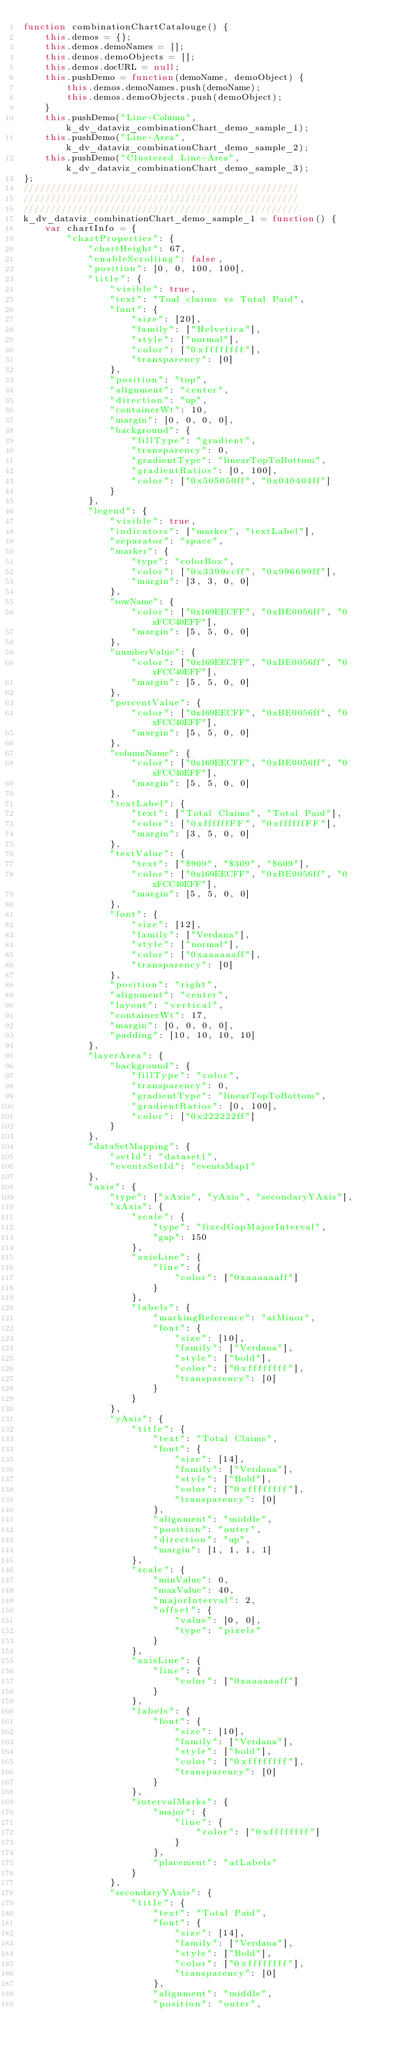<code> <loc_0><loc_0><loc_500><loc_500><_JavaScript_>function combinationChartCatalouge() {
    this.demos = {};
    this.demos.demoNames = [];
    this.demos.demoObjects = [];
    this.demos.docURL = null;
    this.pushDemo = function(demoName, demoObject) {
        this.demos.demoNames.push(demoName);
        this.demos.demoObjects.push(demoObject);
    }
    this.pushDemo("Line+Column", k_dv_dataviz_combinationChart_demo_sample_1);
    this.pushDemo("Line+Area", k_dv_dataviz_combinationChart_demo_sample_2);
    this.pushDemo("Clustered Line+Area", k_dv_dataviz_combinationChart_demo_sample_3);
};
///////////////////////////////////////////////////
///////////////////////////////////////////////////
///////////////////////////////////////////////////
k_dv_dataviz_combinationChart_demo_sample_1 = function() {
    var chartInfo = {
        "chartProperties": {
            "chartHeight": 67,
            "enableScrolling": false,
            "position": [0, 0, 100, 100],
            "title": {
                "visible": true,
                "text": "Toal claims vs Total Paid",
                "font": {
                    "size": [20],
                    "family": ["Helvetica"],
                    "style": ["normal"],
                    "color": ["0xffffffff"],
                    "transparency": [0]
                },
                "position": "top",
                "alignment": "center",
                "direction": "up",
                "containerWt": 10,
                "margin": [0, 0, 0, 0],
                "background": {
                    "fillType": "gradient",
                    "transparency": 0,
                    "gradientType": "linearTopToBottom",
                    "gradientRatios": [0, 100],
                    "color": ["0x505050ff", "0x040404ff"]
                }
            },
            "legend": {
                "visible": true,
                "indicators": ["marker", "textLabel"],
                "separator": "space",
                "marker": {
                    "type": "colorBox",
                    "color": ["0x3399ccff", "0x996699ff"],
                    "margin": [3, 3, 0, 0]
                },
                "rowName": {
                    "color": ["0x169EECFF", "0xBE0056ff", "0xFCC40EFF"],
                    "margin": [5, 5, 0, 0]
                },
                "numberValue": {
                    "color": ["0x169EECFF", "0xBE0056ff", "0xFCC40EFF"],
                    "margin": [5, 5, 0, 0]
                },
                "percentValue": {
                    "color": ["0x169EECFF", "0xBE0056ff", "0xFCC40EFF"],
                    "margin": [5, 5, 0, 0]
                },
                "columnName": {
                    "color": ["0x169EECFF", "0xBE0056ff", "0xFCC40EFF"],
                    "margin": [5, 5, 0, 0]
                },
                "textLabel": {
                    "text": ["Total Claims", "Total Paid"],
                    "color": ["0xffffffFF", "0xffffffFF"],
                    "margin": [3, 5, 0, 0]
                },
                "textValue": {
                    "text": ["$909", "$309", "$609"],
                    "color": ["0x169EECFF", "0xBE0056ff", "0xFCC40EFF"],
                    "margin": [5, 5, 0, 0]
                },
                "font": {
                    "size": [12],
                    "family": ["Verdana"],
                    "style": ["normal"],
                    "color": ["0xaaaaaaff"],
                    "transparency": [0]
                },
                "position": "right",
                "alignment": "center",
                "layout": "vertical",
                "containerWt": 17,
                "margin": [0, 0, 0, 0],
                "padding": [10, 10, 10, 10]
            },
            "layerArea": {
                "background": {
                    "fillType": "color",
                    "transparency": 0,
                    "gradientType": "linearTopToBottom",
                    "gradientRatios": [0, 100],
                    "color": ["0x222222ff"]
                }
            },
            "dataSetMapping": {
                "setId": "dataset1",
                "eventsSetId": "eventsMap1"
            },
            "axis": {
                "type": ["xAxis", "yAxis", "secondaryYAxis"],
                "xAxis": {
                    "scale": {
                        "type": "fixedGapMajorInterval",
                        "gap": 150
                    },
                    "axisLine": {
                        "line": {
                            "color": ["0xaaaaaaff"]
                        }
                    },
                    "labels": {
                        "markingReference": "atMinor",
                        "font": {
                            "size": [10],
                            "family": ["Verdana"],
                            "style": ["bold"],
                            "color": ["0xffffffff"],
                            "transparency": [0]
                        }
                    }
                },
                "yAxis": {
                    "title": {
                        "text": "Total Claims",
                        "font": {
                            "size": [14],
                            "family": ["Verdana"],
                            "style": ["Bold"],
                            "color": ["0xffffffff"],
                            "transparency": [0]
                        },
                        "alignment": "middle",
                        "position": "outer",
                        "direction": "up",
                        "margin": [1, 1, 1, 1]
                    },
                    "scale": {
                        "minValue": 0,
                        "maxValue": 40,
                        "majorInterval": 2,
                        "offset": {
                            "value": [0, 0],
                            "type": "pixels"
                        }
                    },
                    "axisLine": {
                        "line": {
                            "color": ["0xaaaaaaff"]
                        }
                    },
                    "labels": {
                        "font": {
                            "size": [10],
                            "family": ["Verdana"],
                            "style": ["bold"],
                            "color": ["0xffffffff"],
                            "transparency": [0]
                        }
                    },
                    "intervalMarks": {
                        "major": {
                            "line": {
                                "color": ["0xffffffff"]
                            }
                        },
                        "placement": "atLabels"
                    }
                },
                "secondaryYAxis": {
                    "title": {
                        "text": "Total Paid",
                        "font": {
                            "size": [14],
                            "family": ["Verdana"],
                            "style": ["Bold"],
                            "color": ["0xffffffff"],
                            "transparency": [0]
                        },
                        "alignment": "middle",
                        "position": "outer",</code> 